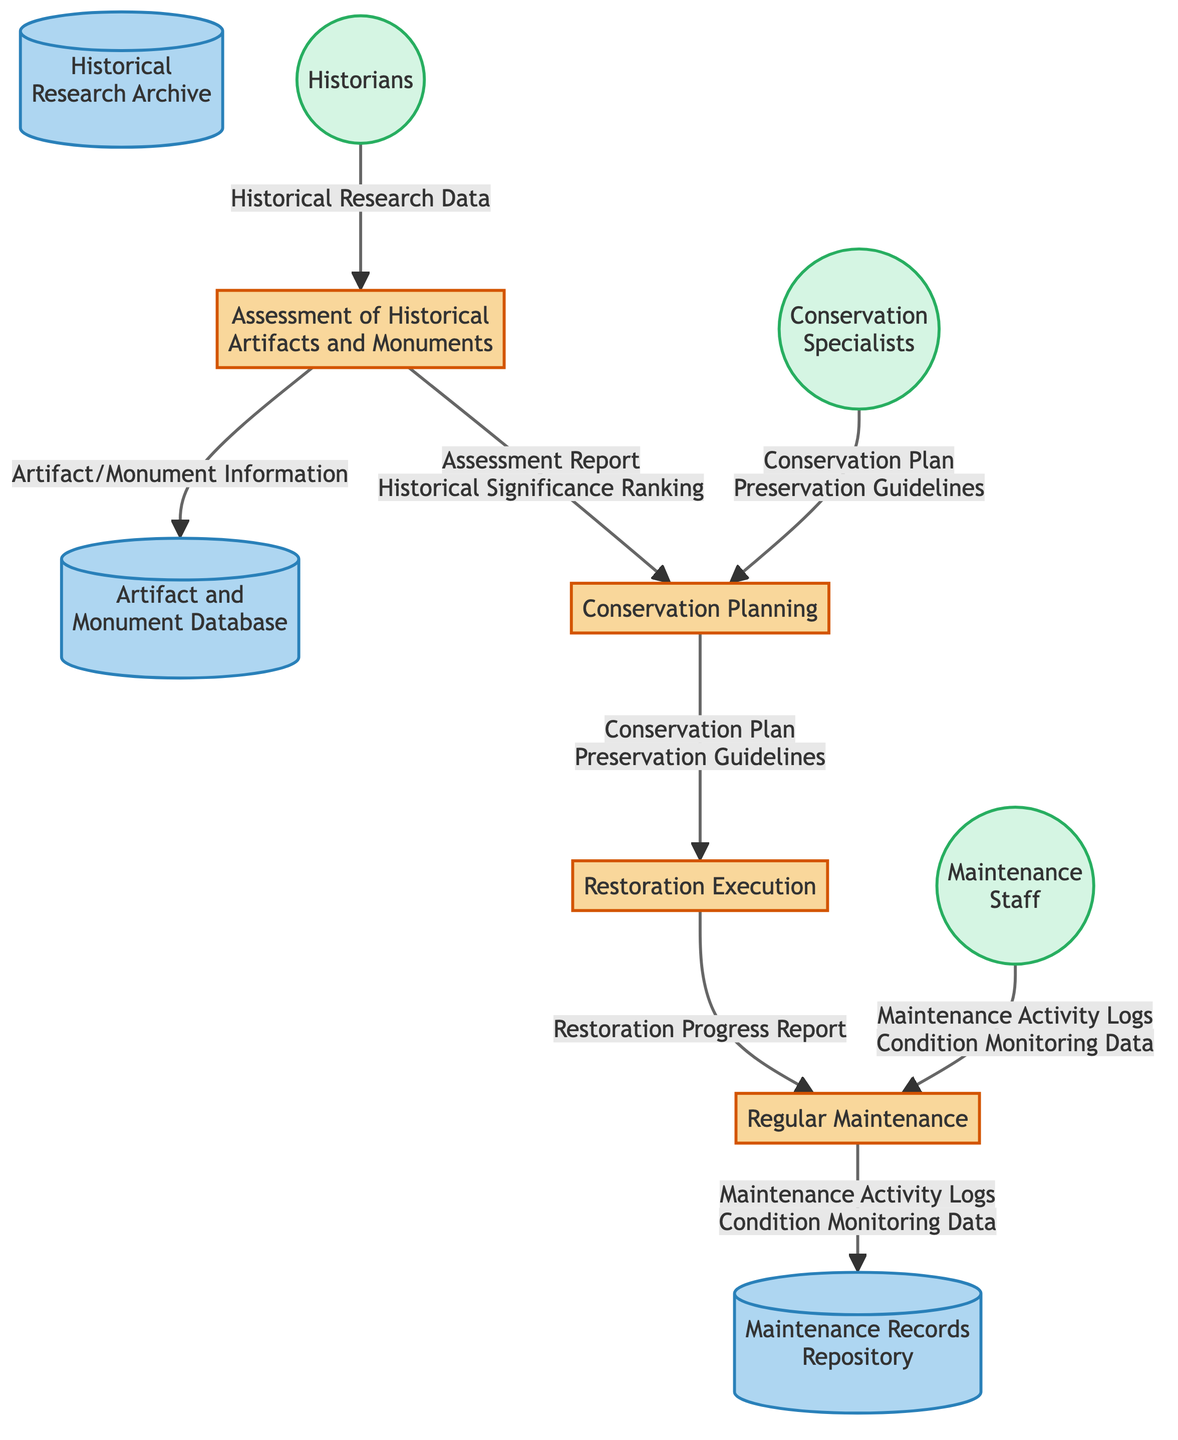What is the first process in the workflow? The first process is labeled as "Assessment of Historical Artifacts and Monuments," which can be identified at the top section of the diagram.
Answer: Assessment of Historical Artifacts and Monuments How many processes are depicted in the diagram? By counting the boxes labeled as processes, there are a total of four processes in the diagram.
Answer: 4 Which external entity provides historical research data? The external entity that supplies "Historical Research Data" is labeled as "Historians," which is connected to the first process in the flow.
Answer: Historians What is the output of the "Conservation Planning" process? The "Conservation Planning" process outputs "Conservation Plan" and "Preservation Guidelines," which are indicated next to the process box.
Answer: Conservation Plan, Preservation Guidelines What data flows from "Regular Maintenance" to Data Store 3? The data that flows from the "Regular Maintenance" process to the Maintenance Records Repository (Data Store 3) includes "Maintenance Activity Logs" and "Condition Monitoring Data."
Answer: Maintenance Activity Logs, Condition Monitoring Data What is the relationship between "Assessment of Historical Artifacts and Monuments" and "Conservation Planning"? The relationship is that the output of the "Assessment of Historical Artifacts and Monuments" process feeds into "Conservation Planning" as inputs. Specifically, the outputs are "Assessment Report" and "Historical Significance Ranking."
Answer: Assessment Report, Historical Significance Ranking Which process does the "Restoration Execution" receive inputs from? The "Restoration Execution" process receives inputs from "Conservation Planning," as indicated by the flow of data from the second process to the third.
Answer: Conservation Planning How many data stores are present in the diagram? The diagram contains three data stores labeled as "Artifact and Monument Database," "Historical Research Archive," and "Maintenance Records Repository." Counting these gives a total of three data stores.
Answer: 3 What is the final process in the workflow chain? The final process in the workflow chain is "Regular Maintenance," situated at the bottom of the diagram as the last process after "Restoration Execution."
Answer: Regular Maintenance 